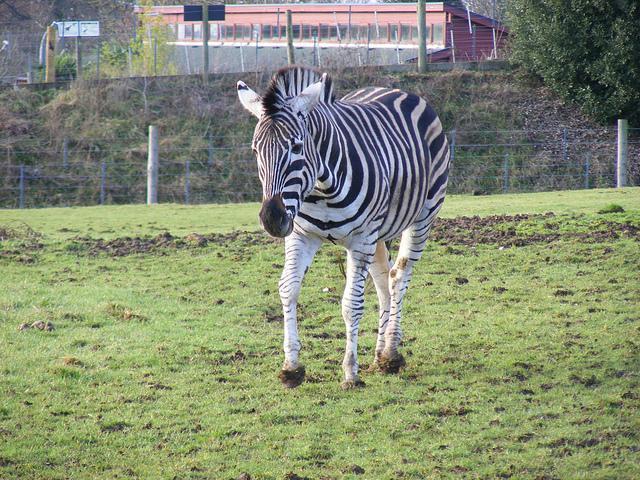How many brown horses are there?
Give a very brief answer. 0. 